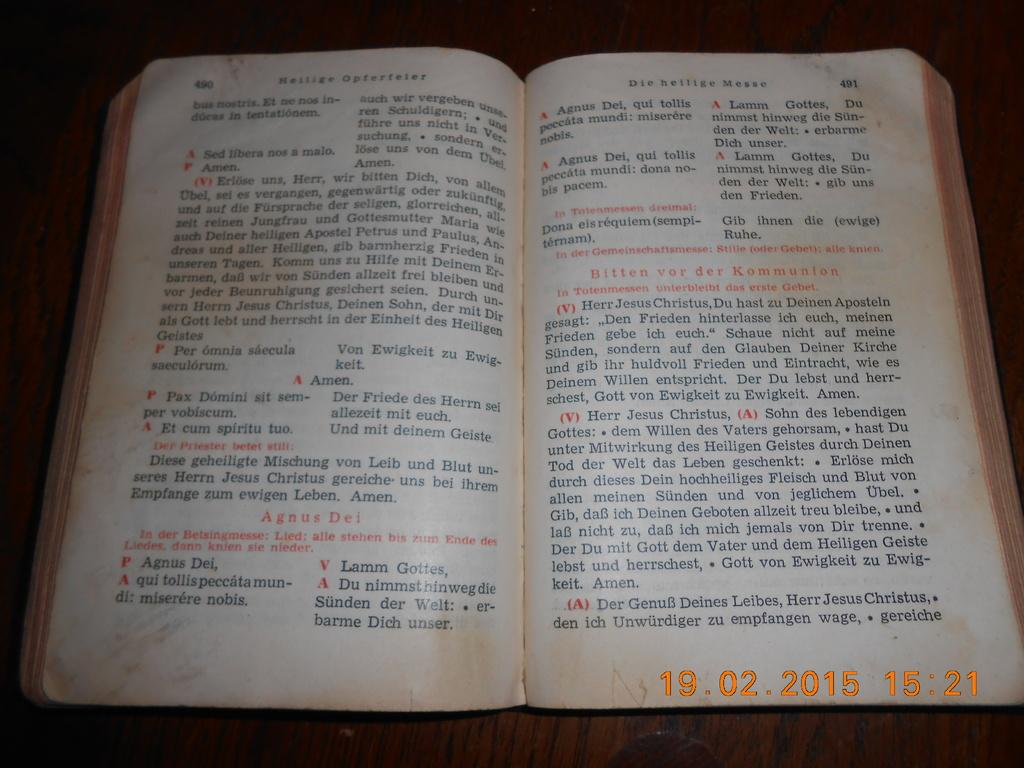<image>
Write a terse but informative summary of the picture. An old book in dutch text with the passage pertaining to Bitten vor der Kommunion. 